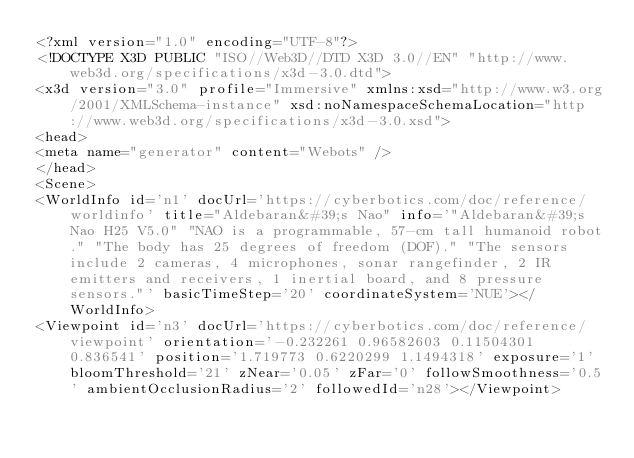Convert code to text. <code><loc_0><loc_0><loc_500><loc_500><_XML_><?xml version="1.0" encoding="UTF-8"?>
<!DOCTYPE X3D PUBLIC "ISO//Web3D//DTD X3D 3.0//EN" "http://www.web3d.org/specifications/x3d-3.0.dtd">
<x3d version="3.0" profile="Immersive" xmlns:xsd="http://www.w3.org/2001/XMLSchema-instance" xsd:noNamespaceSchemaLocation="http://www.web3d.org/specifications/x3d-3.0.xsd">
<head>
<meta name="generator" content="Webots" />
</head>
<Scene>
<WorldInfo id='n1' docUrl='https://cyberbotics.com/doc/reference/worldinfo' title="Aldebaran&#39;s Nao" info='"Aldebaran&#39;s Nao H25 V5.0" "NAO is a programmable, 57-cm tall humanoid robot." "The body has 25 degrees of freedom (DOF)." "The sensors include 2 cameras, 4 microphones, sonar rangefinder, 2 IR emitters and receivers, 1 inertial board, and 8 pressure sensors."' basicTimeStep='20' coordinateSystem='NUE'></WorldInfo>
<Viewpoint id='n3' docUrl='https://cyberbotics.com/doc/reference/viewpoint' orientation='-0.232261 0.96582603 0.11504301 0.836541' position='1.719773 0.6220299 1.1494318' exposure='1' bloomThreshold='21' zNear='0.05' zFar='0' followSmoothness='0.5' ambientOcclusionRadius='2' followedId='n28'></Viewpoint></code> 